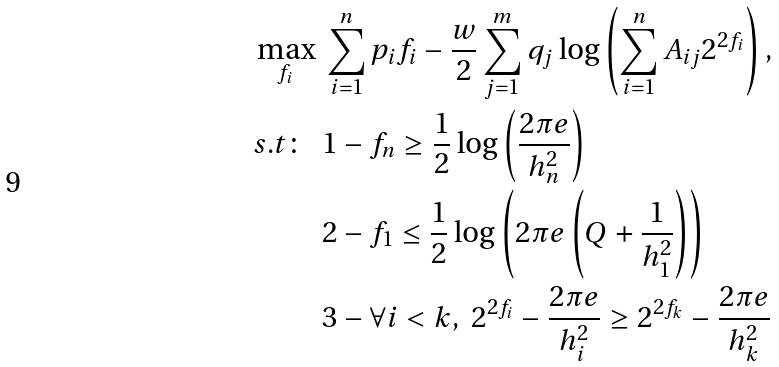Convert formula to latex. <formula><loc_0><loc_0><loc_500><loc_500>\max _ { f _ { i } } \ & \sum _ { i = 1 } ^ { n } p _ { i } f _ { i } - \frac { w } { 2 } \sum _ { j = 1 } ^ { m } q _ { j } \log \left ( \sum _ { i = 1 } ^ { n } A _ { i j } 2 ^ { 2 f _ { i } } \right ) , \\ s . t \colon \ \ & 1 - f _ { n } \geq \frac { 1 } { 2 } \log \left ( \frac { 2 \pi e } { h _ { n } ^ { 2 } } \right ) \\ & 2 - f _ { 1 } \leq \frac { 1 } { 2 } \log \left ( 2 \pi e \left ( Q + \frac { 1 } { h _ { 1 } ^ { 2 } } \right ) \right ) \\ & 3 - \forall i < k , \ 2 ^ { 2 f _ { i } } - \frac { 2 \pi e } { h _ { i } ^ { 2 } } \geq 2 ^ { 2 f _ { k } } - \frac { 2 \pi e } { h _ { k } ^ { 2 } }</formula> 